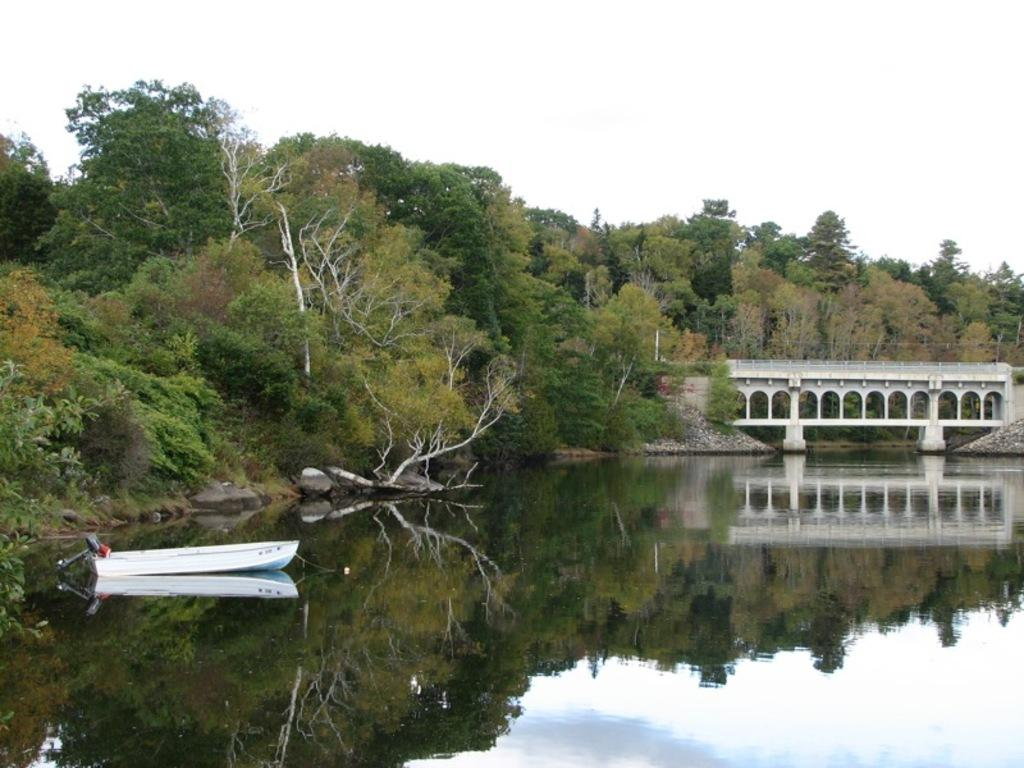What is located in the water in the foreground of the image? There is a boat in the water in the foreground of the image. What structure can be seen to the right side of the image? There is a bridge to the right side of the image. What type of vegetation is visible in the background of the image? There are trees visible in the background of the image. What else can be seen in the background of the image? The sky is visible in the background of the image. How many mittens are hanging on the trees in the image? There are no mittens present in the image; it features a boat in the water, a bridge, trees, and the sky. What type of pets can be seen playing on the bridge in the image? There are no pets present in the image; it only features a boat, a bridge, trees, and the sky. 